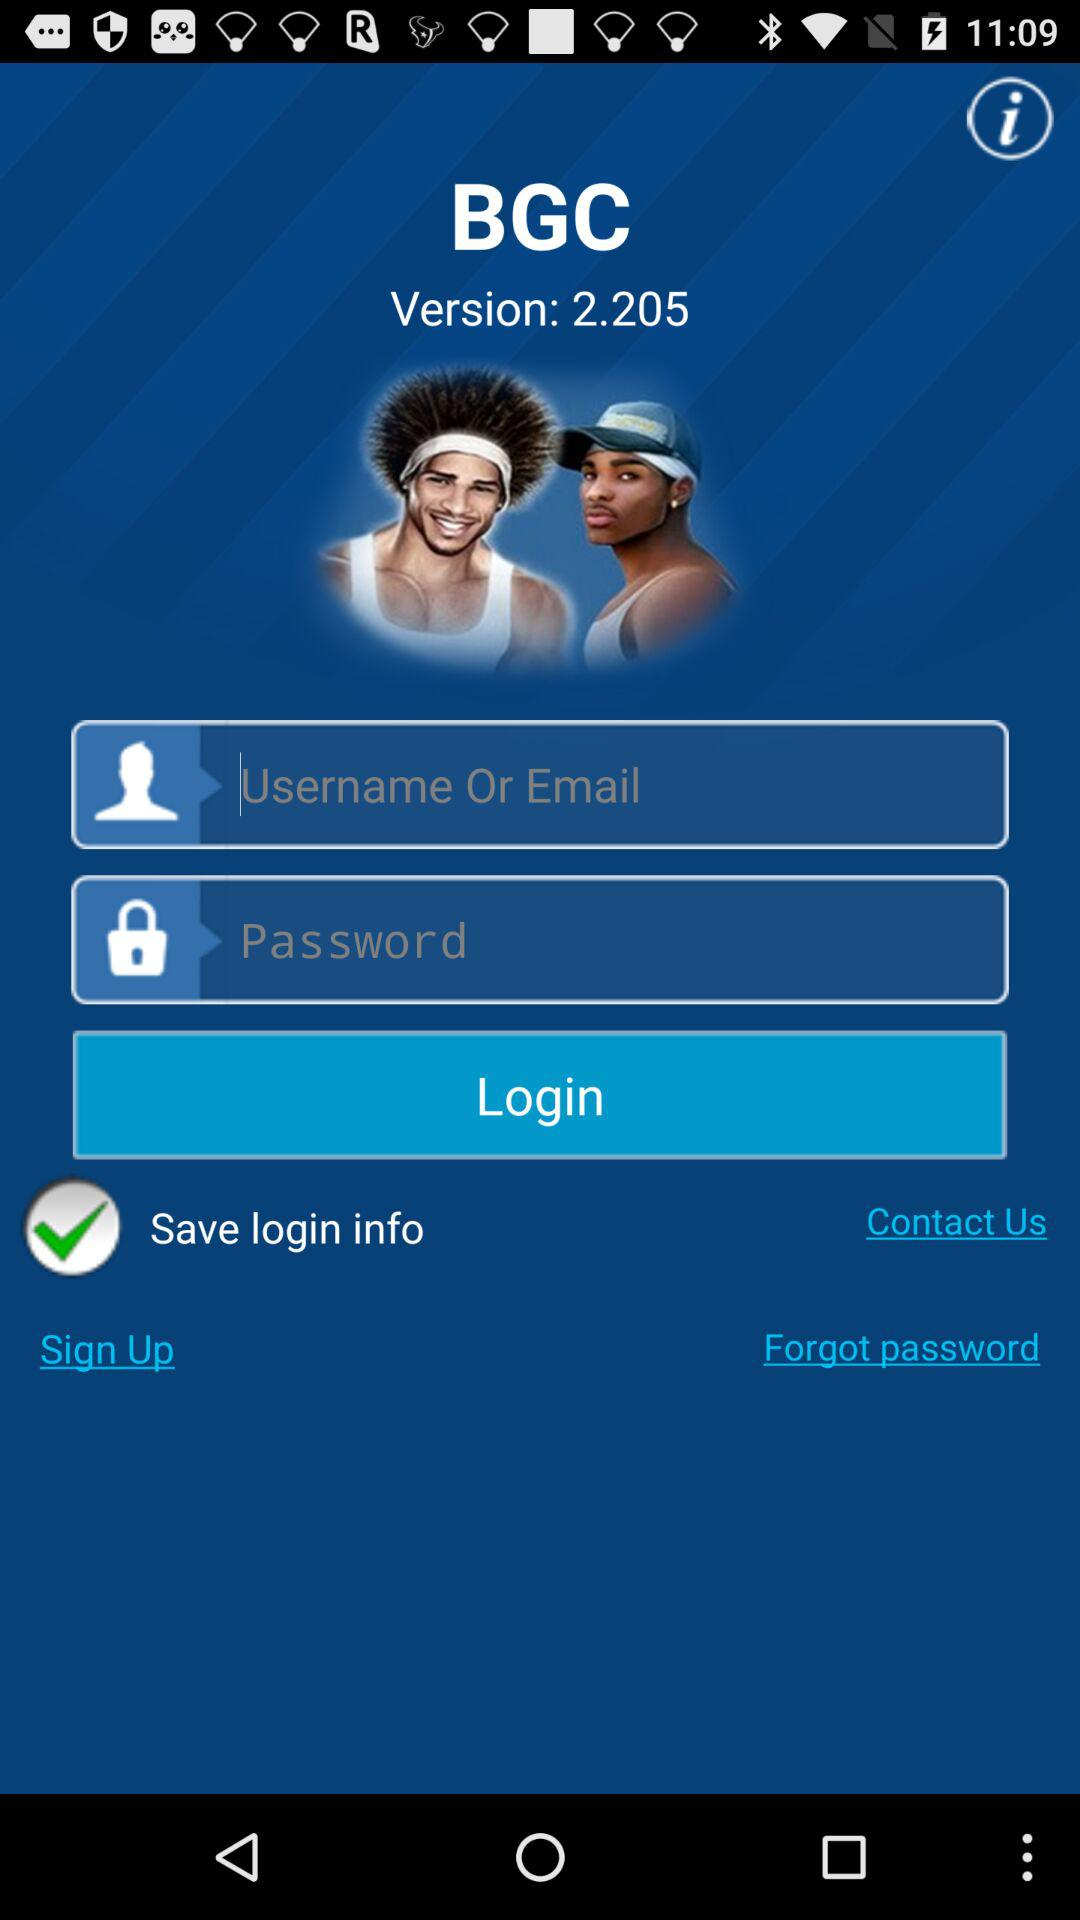What's the status of "Save login info"? The status is "on". 